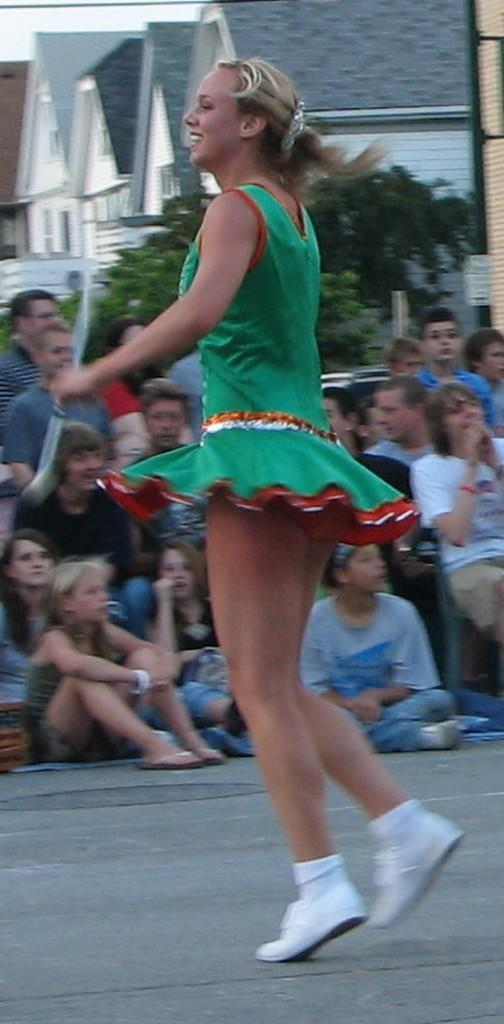Who is the main subject in the image? There is a lady in the center of the image. What can be seen in the background of the image? There are people, buildings, trees, and a board in the background of the image. What is at the bottom of the image? There is a road at the bottom of the image. What type of knee injury can be seen in the image? There is no knee injury present in the image. Where is the playground located in the image? There is no playground present in the image. 